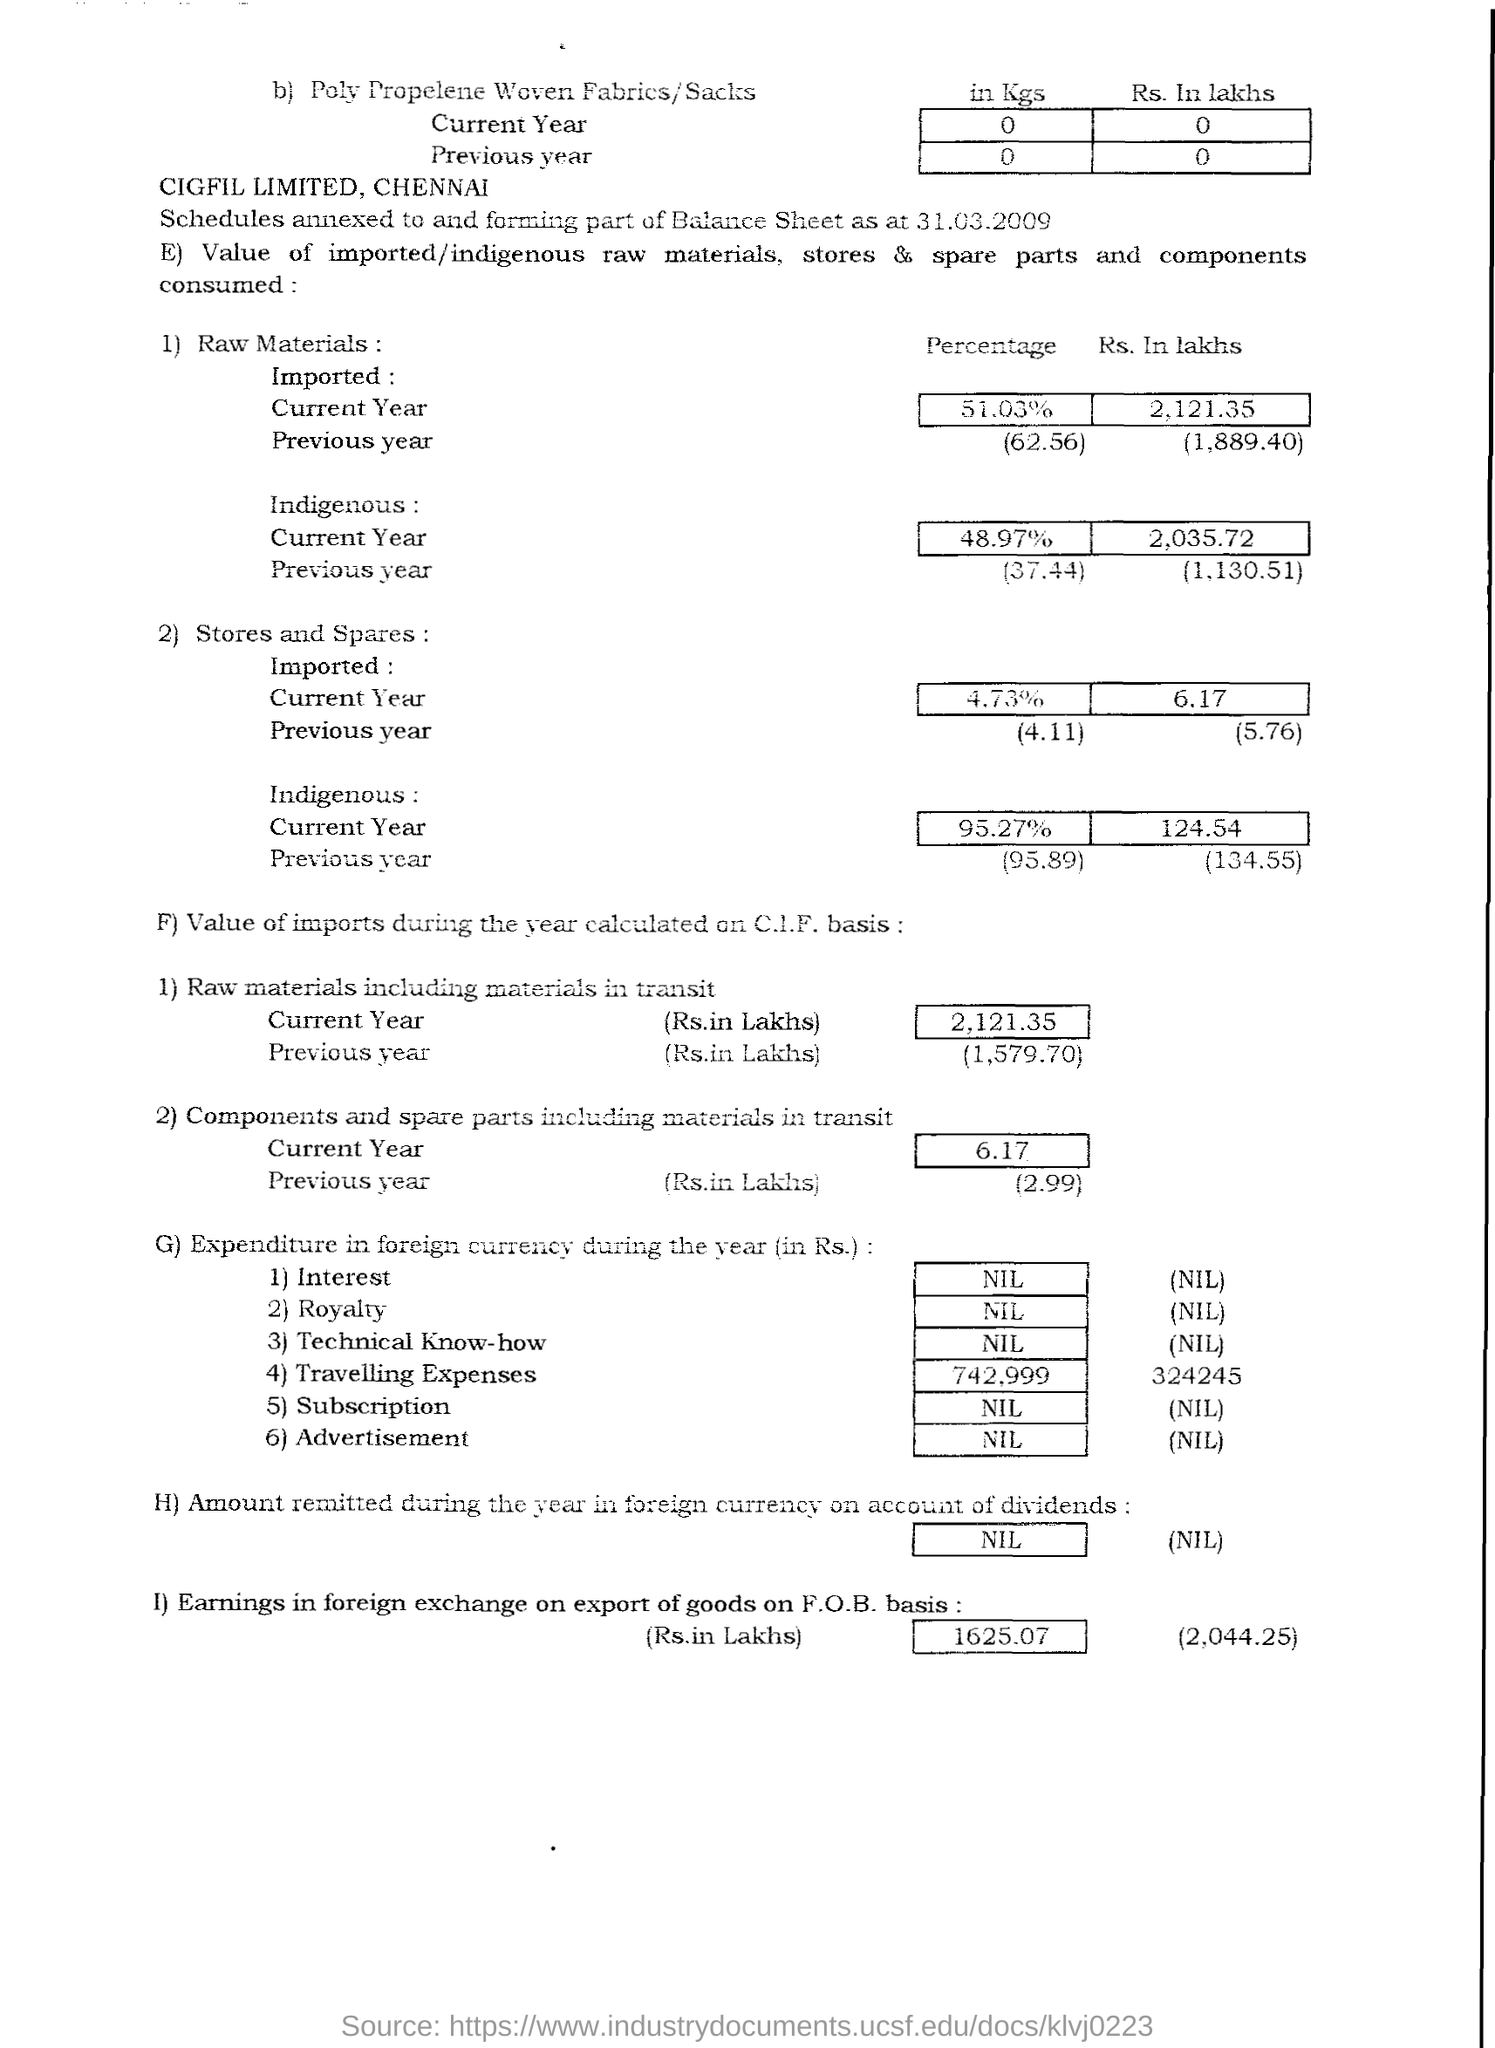Outline some significant characteristics in this image. The current year's raw materials consist of 48.97% of indigenous materials. What is the percentage of stores and spares imported in the previous year? 4.11... The percentage of raw materials imported in the previous year was 62.56. In the previous year, the percentage of stores and spares that were indigenous was 95.89. According to the current data, approximately 4.73% of all stores and spares imported this year. 